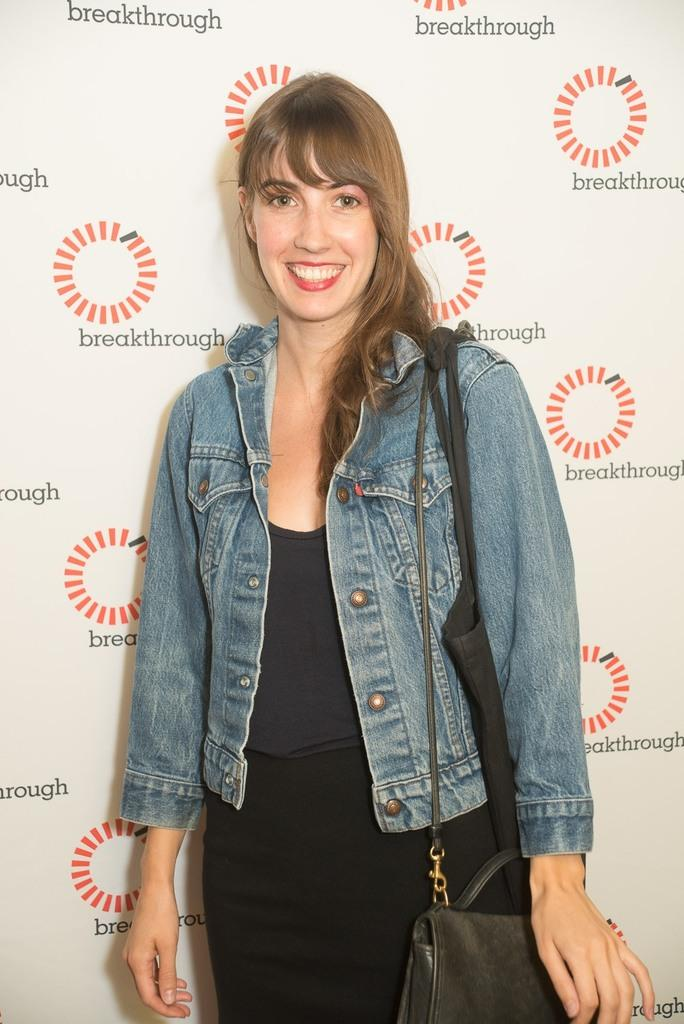Who is the main subject in the image? There is a woman in the image. What is the woman doing in the image? The woman is standing. What is the woman holding in the image? The woman is carrying a bag. What is the woman's facial expression in the image? The woman has a smile on her face. What type of growth can be seen on the woman's face in the image? There is no growth visible on the woman's face in the image. 